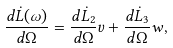Convert formula to latex. <formula><loc_0><loc_0><loc_500><loc_500>\frac { d \dot { L } ( { \omega } ) } { d \Omega } = \frac { d \dot { L } _ { 2 } } { d \Omega } v + \frac { d \dot { L } _ { 3 } } { d \Omega } w ,</formula> 